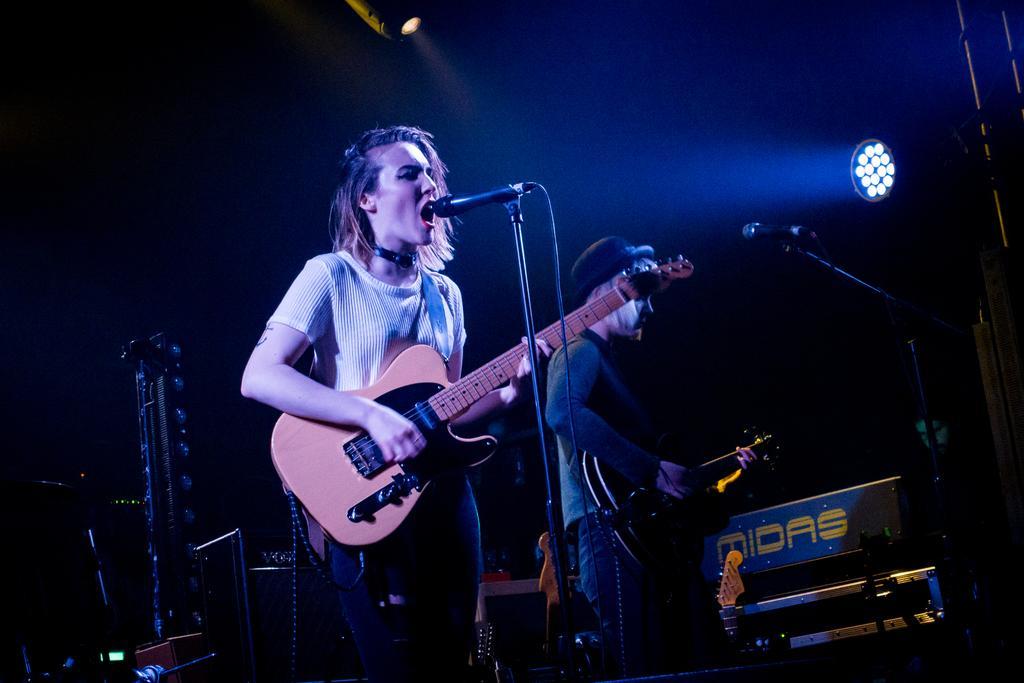Describe this image in one or two sentences. There is a girl holding a guitar and standing in front of a mic in the foreground area of the image, there is another boy holding a guitar and standing in front of a mic, there are spotlights and the background is black. 